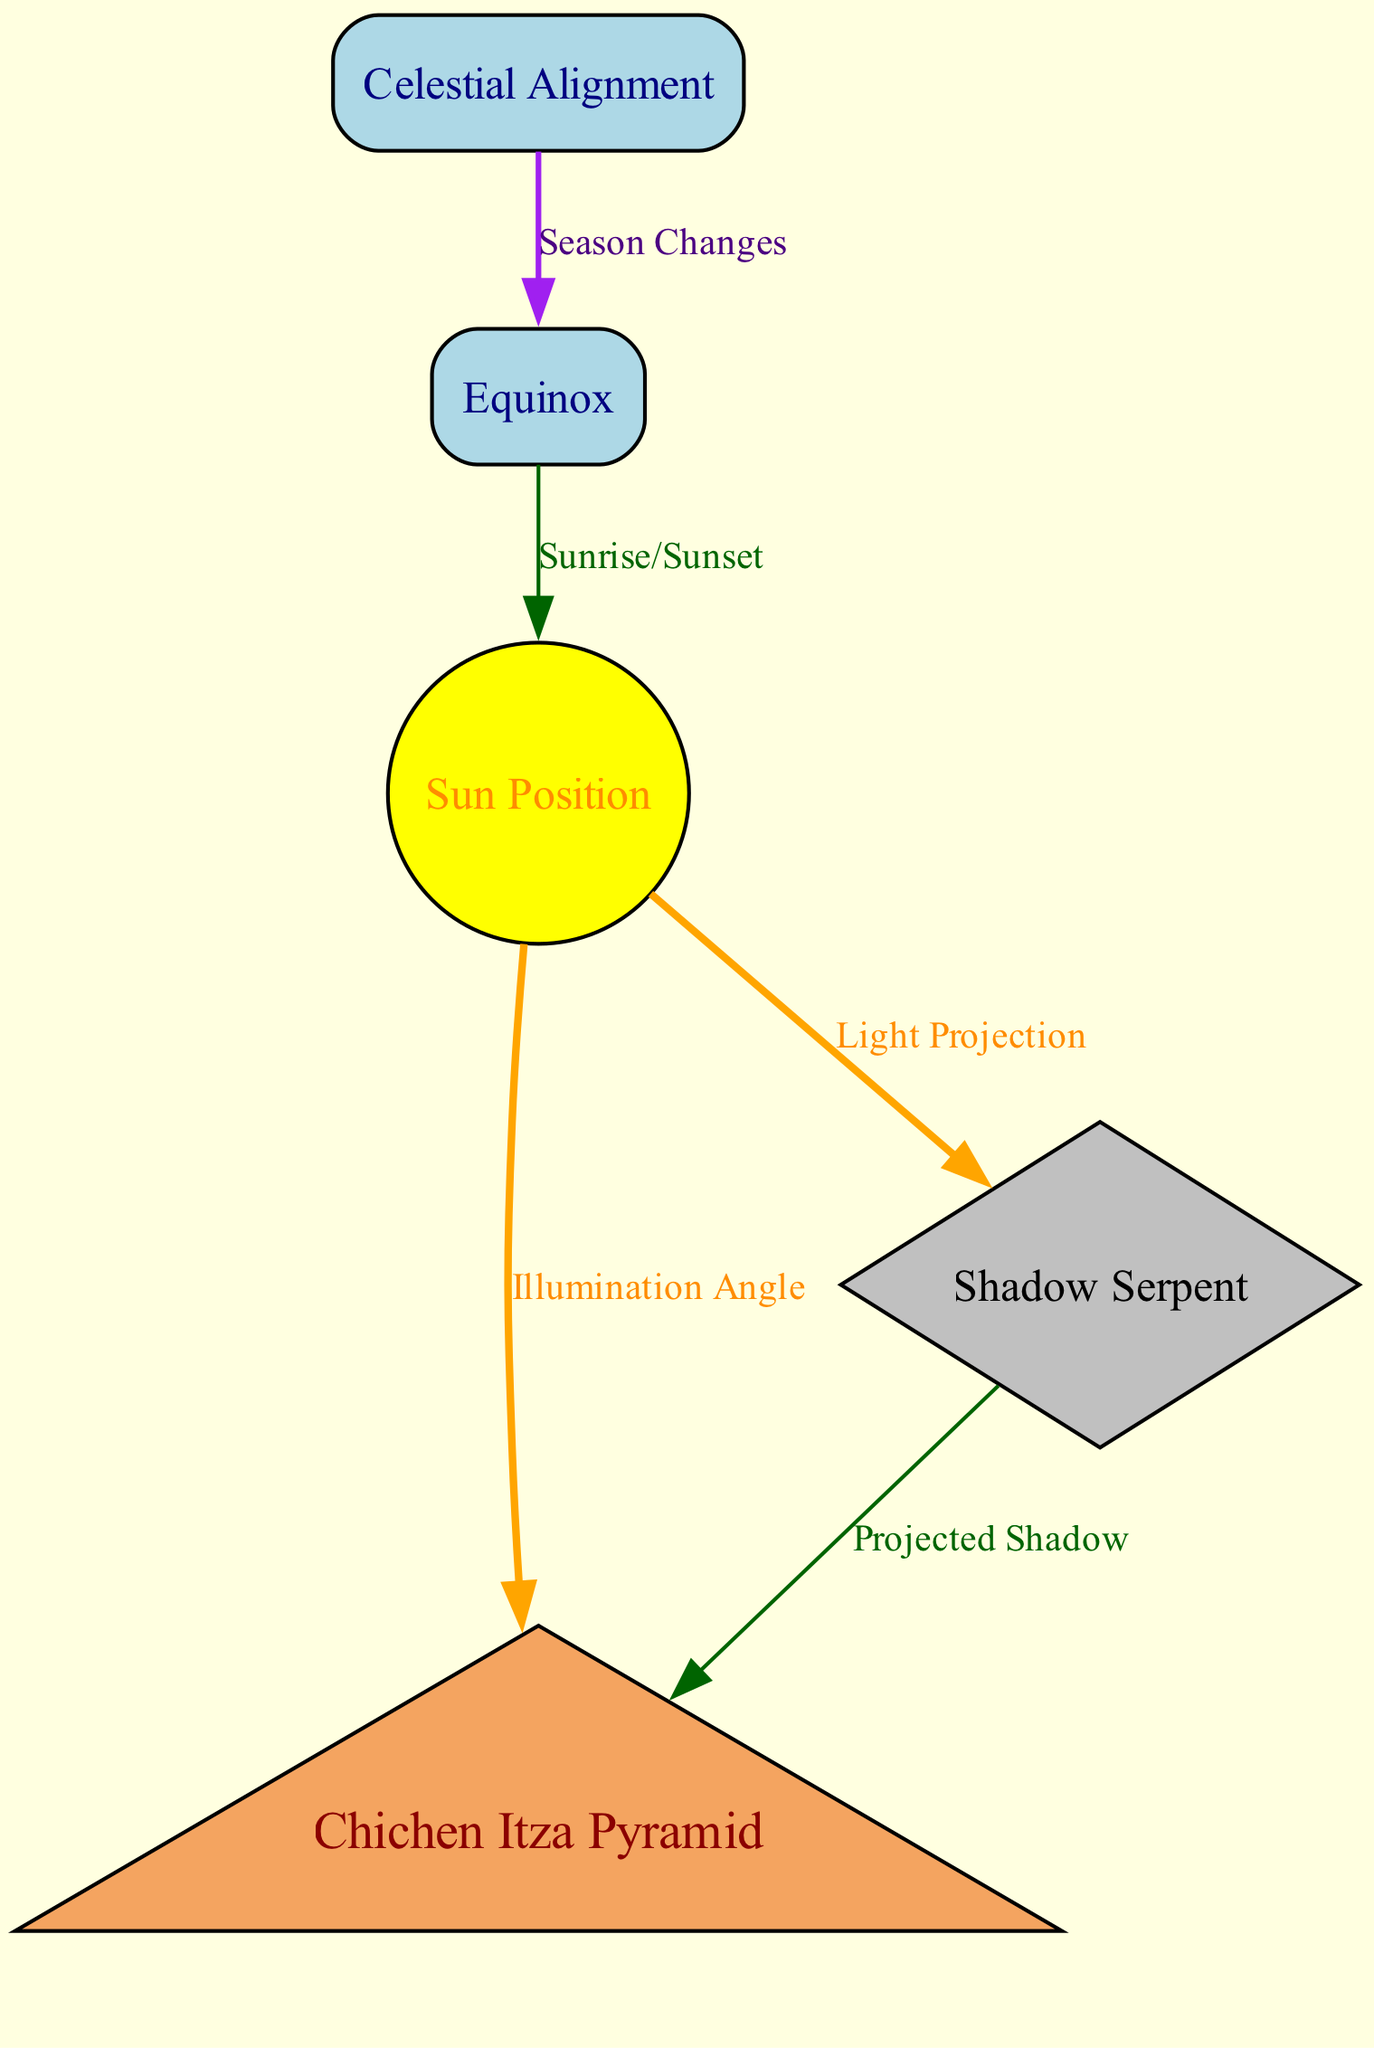What is the total number of nodes in the diagram? The diagram has five nodes: the Chichen Itza Pyramid, Equinox, Shadow Serpent, Sun Position, and Celestial Alignment. By simply counting these nodes, the total is determined.
Answer: 5 What type of node is the Chichen Itza Pyramid? In the diagram, the Chichen Itza Pyramid is represented as a triangle shape. This can be identified by examining the shape designation for the corresponding node.
Answer: Triangle What is the color of the Sun Position node? The Sun Position node is filled with yellow color, which is specified in the node's graphical attributes. Observing this color fills the node confirms the answer.
Answer: Yellow How many edges are directed from the Sun Position node? The Sun Position node has two edges directed from it: one to the Chichen Itza Pyramid (Illumination Angle) and another to the Shadow Serpent (Light Projection). Counting these edges leads to the conclusion.
Answer: 2 What relationship connects the Equinox to the Sun Position? The relationship between the Equinox and the Sun Position is described as "Sunrise/Sunset," which is labeled on the edge connecting these two nodes.
Answer: Sunrise/Sunset Which node is connected to the Celestial Alignment? The Celestial Alignment node is connected to the Equinox. This can be confirmed by following the edge in the diagram that links these two nodes.
Answer: Equinox What shape does the Shadow Serpent node have? The Shadow Serpent node is represented as a diamond shape in the diagram. This can be verified by its shape specification in the node attributes.
Answer: Diamond How does the Sun Position affect the Shadow Serpent? The Sun Position influences the Shadow Serpent through the relationship labeled as "Light Projection." This edge indicates the direct interaction between the two nodes.
Answer: Light Projection What season changes relate to the Celestial Alignment? The relationship connecting the Celestial Alignment and Equinox is labeled "Season Changes," indicating that the changes in celestial events are associated with the equinoxes.
Answer: Season Changes 